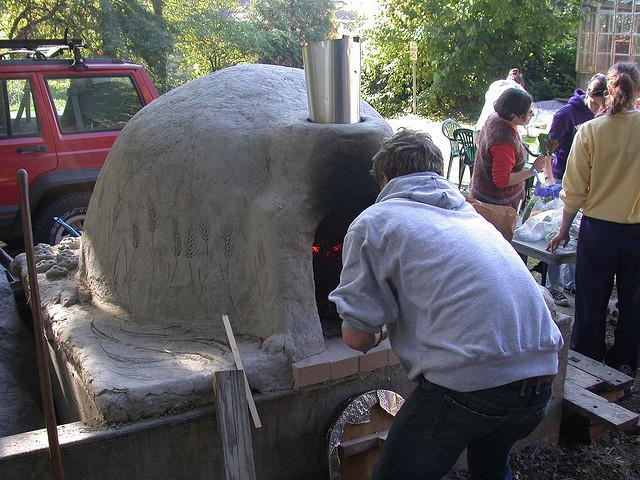In what location was this oven built? backyard 